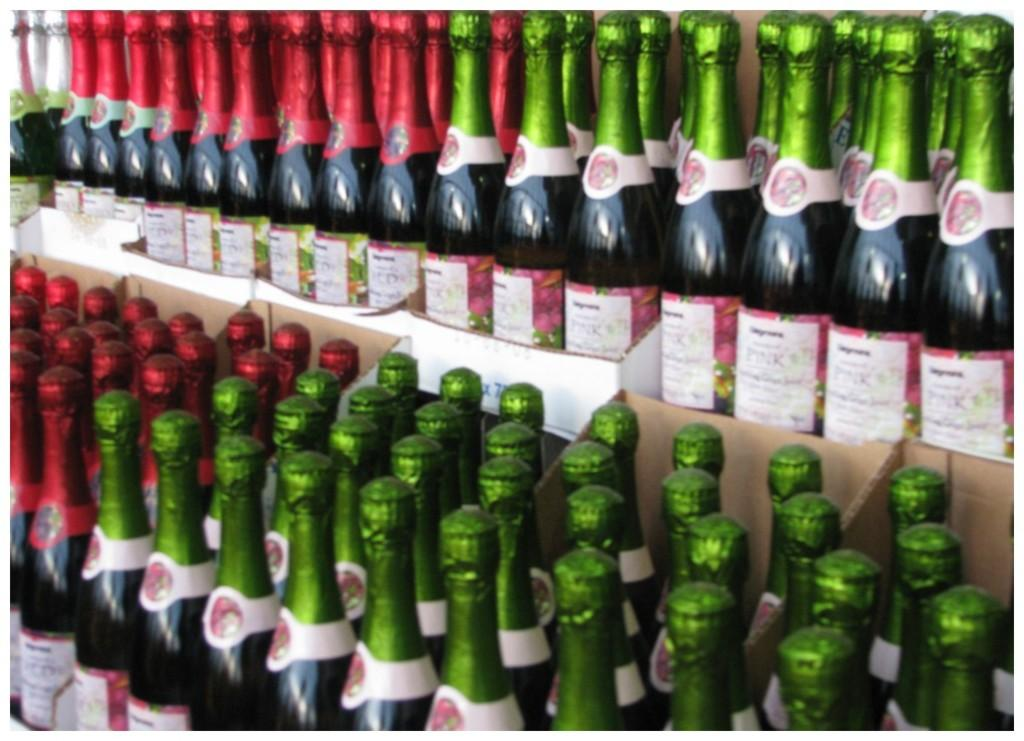<image>
Write a terse but informative summary of the picture. Several bottles of similar brand champagne with green and red foil cap coverings and the word Pink on the label of the green foil ones. 